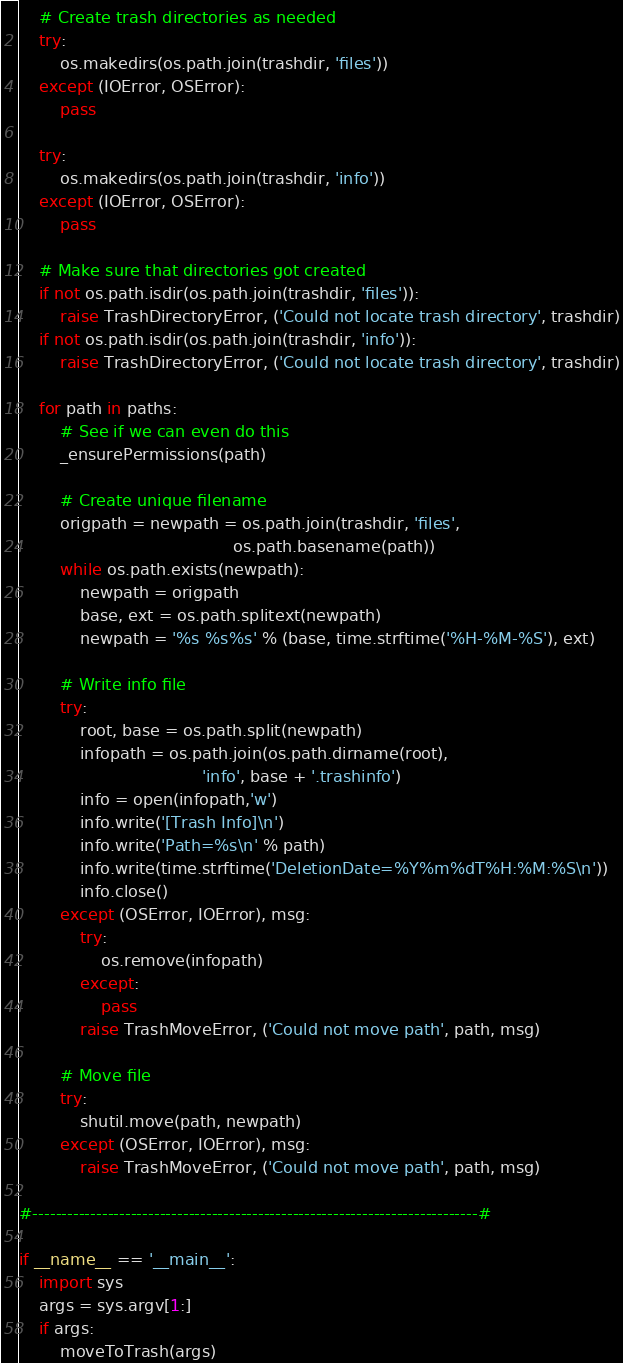Convert code to text. <code><loc_0><loc_0><loc_500><loc_500><_Python_>
    # Create trash directories as needed
    try:
        os.makedirs(os.path.join(trashdir, 'files'))
    except (IOError, OSError):
        pass    

    try:
        os.makedirs(os.path.join(trashdir, 'info'))
    except (IOError, OSError):
        pass
    
    # Make sure that directories got created
    if not os.path.isdir(os.path.join(trashdir, 'files')):
        raise TrashDirectoryError, ('Could not locate trash directory', trashdir)
    if not os.path.isdir(os.path.join(trashdir, 'info')):
        raise TrashDirectoryError, ('Could not locate trash directory', trashdir)
    
    for path in paths:
        # See if we can even do this
        _ensurePermissions(path)
        
        # Create unique filename
        origpath = newpath = os.path.join(trashdir, 'files', 
                                          os.path.basename(path))
        while os.path.exists(newpath):
            newpath = origpath
            base, ext = os.path.splitext(newpath)
            newpath = '%s %s%s' % (base, time.strftime('%H-%M-%S'), ext)

        # Write info file
        try:
            root, base = os.path.split(newpath)
            infopath = os.path.join(os.path.dirname(root), 
                                    'info', base + '.trashinfo')
            info = open(infopath,'w')
            info.write('[Trash Info]\n')
            info.write('Path=%s\n' % path)
            info.write(time.strftime('DeletionDate=%Y%m%dT%H:%M:%S\n'))
            info.close()
        except (OSError, IOError), msg:
            try:
                os.remove(infopath)
            except:
                pass
            raise TrashMoveError, ('Could not move path', path, msg)

        # Move file
        try:
            shutil.move(path, newpath)
        except (OSError, IOError), msg:
            raise TrashMoveError, ('Could not move path', path, msg)

#-----------------------------------------------------------------------------#

if __name__ == '__main__':
    import sys
    args = sys.argv[1:]
    if args:
        moveToTrash(args)
</code> 